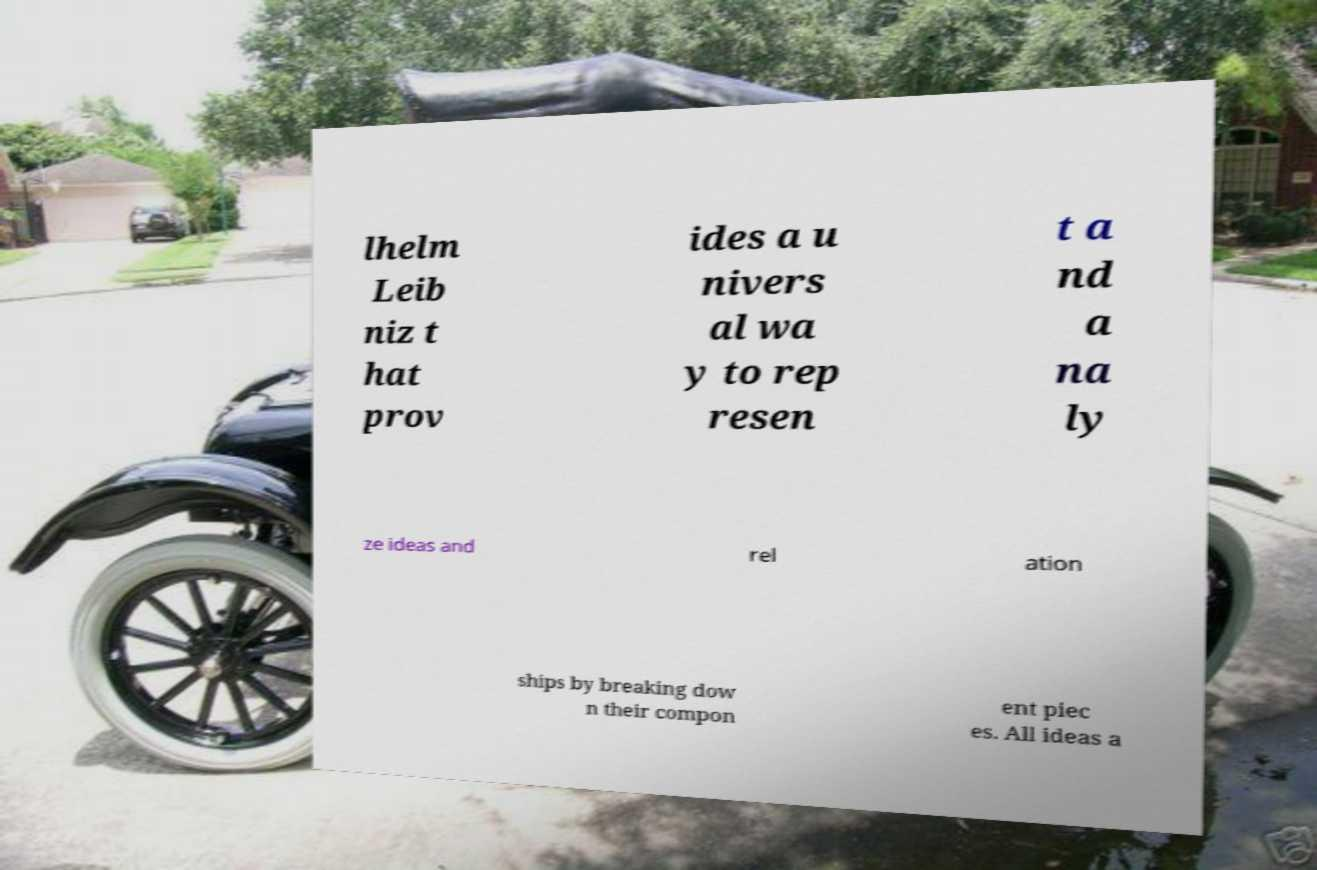There's text embedded in this image that I need extracted. Can you transcribe it verbatim? lhelm Leib niz t hat prov ides a u nivers al wa y to rep resen t a nd a na ly ze ideas and rel ation ships by breaking dow n their compon ent piec es. All ideas a 